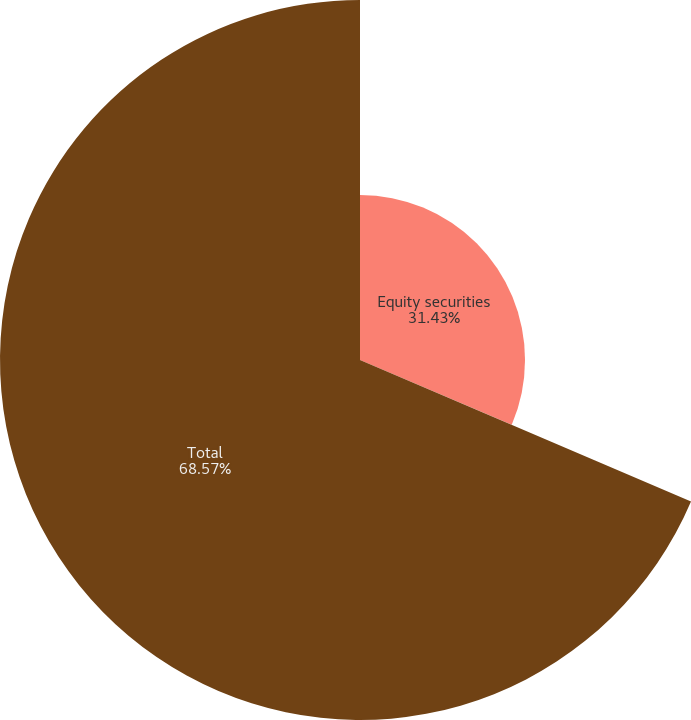Convert chart. <chart><loc_0><loc_0><loc_500><loc_500><pie_chart><fcel>Equity securities<fcel>Total<nl><fcel>31.43%<fcel>68.57%<nl></chart> 